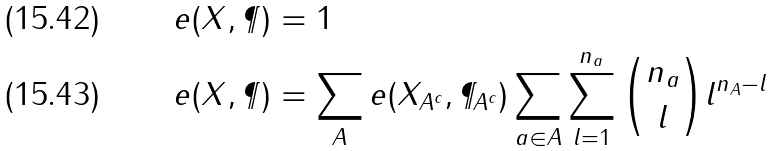Convert formula to latex. <formula><loc_0><loc_0><loc_500><loc_500>e ( X , \P ) & = 1 & & \\ e ( X , \P ) & = \sum _ { A } e ( X _ { A ^ { c } } , \P _ { A ^ { c } } ) \sum _ { a \in A } \sum _ { l = 1 } ^ { n _ { a } } { n _ { a } \choose l } l ^ { n _ { A } - l } & &</formula> 